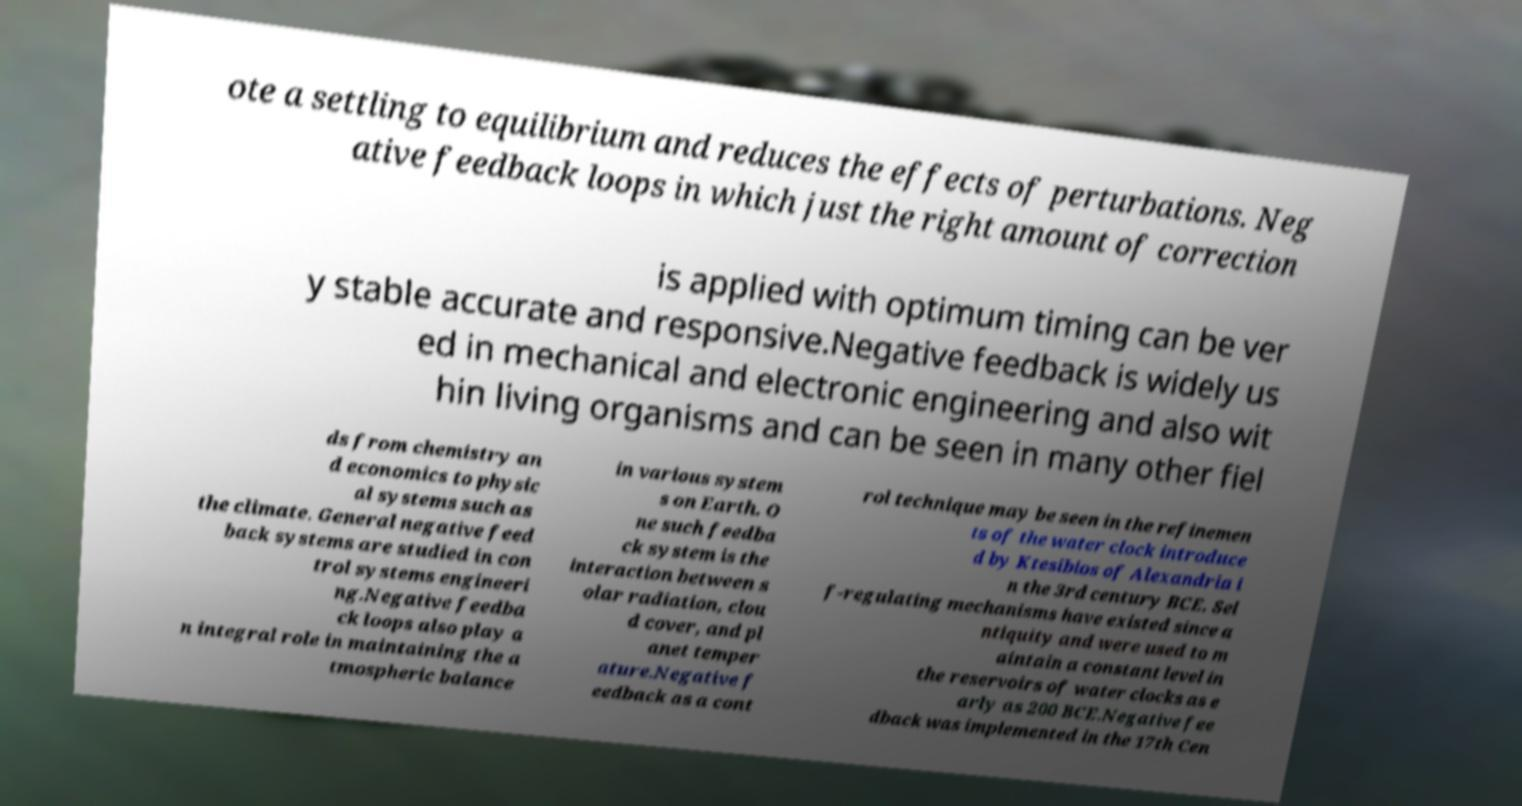Please identify and transcribe the text found in this image. ote a settling to equilibrium and reduces the effects of perturbations. Neg ative feedback loops in which just the right amount of correction is applied with optimum timing can be ver y stable accurate and responsive.Negative feedback is widely us ed in mechanical and electronic engineering and also wit hin living organisms and can be seen in many other fiel ds from chemistry an d economics to physic al systems such as the climate. General negative feed back systems are studied in con trol systems engineeri ng.Negative feedba ck loops also play a n integral role in maintaining the a tmospheric balance in various system s on Earth. O ne such feedba ck system is the interaction between s olar radiation, clou d cover, and pl anet temper ature.Negative f eedback as a cont rol technique may be seen in the refinemen ts of the water clock introduce d by Ktesibios of Alexandria i n the 3rd century BCE. Sel f-regulating mechanisms have existed since a ntiquity and were used to m aintain a constant level in the reservoirs of water clocks as e arly as 200 BCE.Negative fee dback was implemented in the 17th Cen 